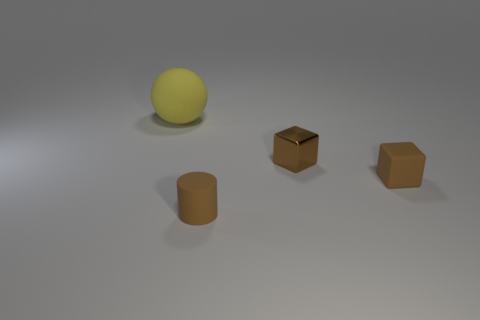Are there any other things that are the same size as the yellow ball?
Your answer should be compact. No. Are there any other things that are the same shape as the yellow rubber thing?
Ensure brevity in your answer.  No. How many small purple cylinders are made of the same material as the big yellow ball?
Make the answer very short. 0. Is the size of the rubber object that is right of the metal block the same as the brown rubber object that is in front of the small brown matte cube?
Offer a terse response. Yes. There is a small matte thing to the right of the brown rubber object in front of the small brown rubber cube that is right of the brown metal cube; what color is it?
Provide a succinct answer. Brown. Are there any other brown objects of the same shape as the tiny shiny object?
Your response must be concise. Yes. Is the number of brown cubes that are left of the yellow sphere the same as the number of brown rubber objects that are on the right side of the tiny brown matte cylinder?
Provide a short and direct response. No. Does the small matte object right of the cylinder have the same shape as the tiny shiny thing?
Your answer should be compact. Yes. Does the yellow object have the same shape as the metal object?
Your response must be concise. No. What number of rubber objects are either brown cubes or brown cylinders?
Your response must be concise. 2. 